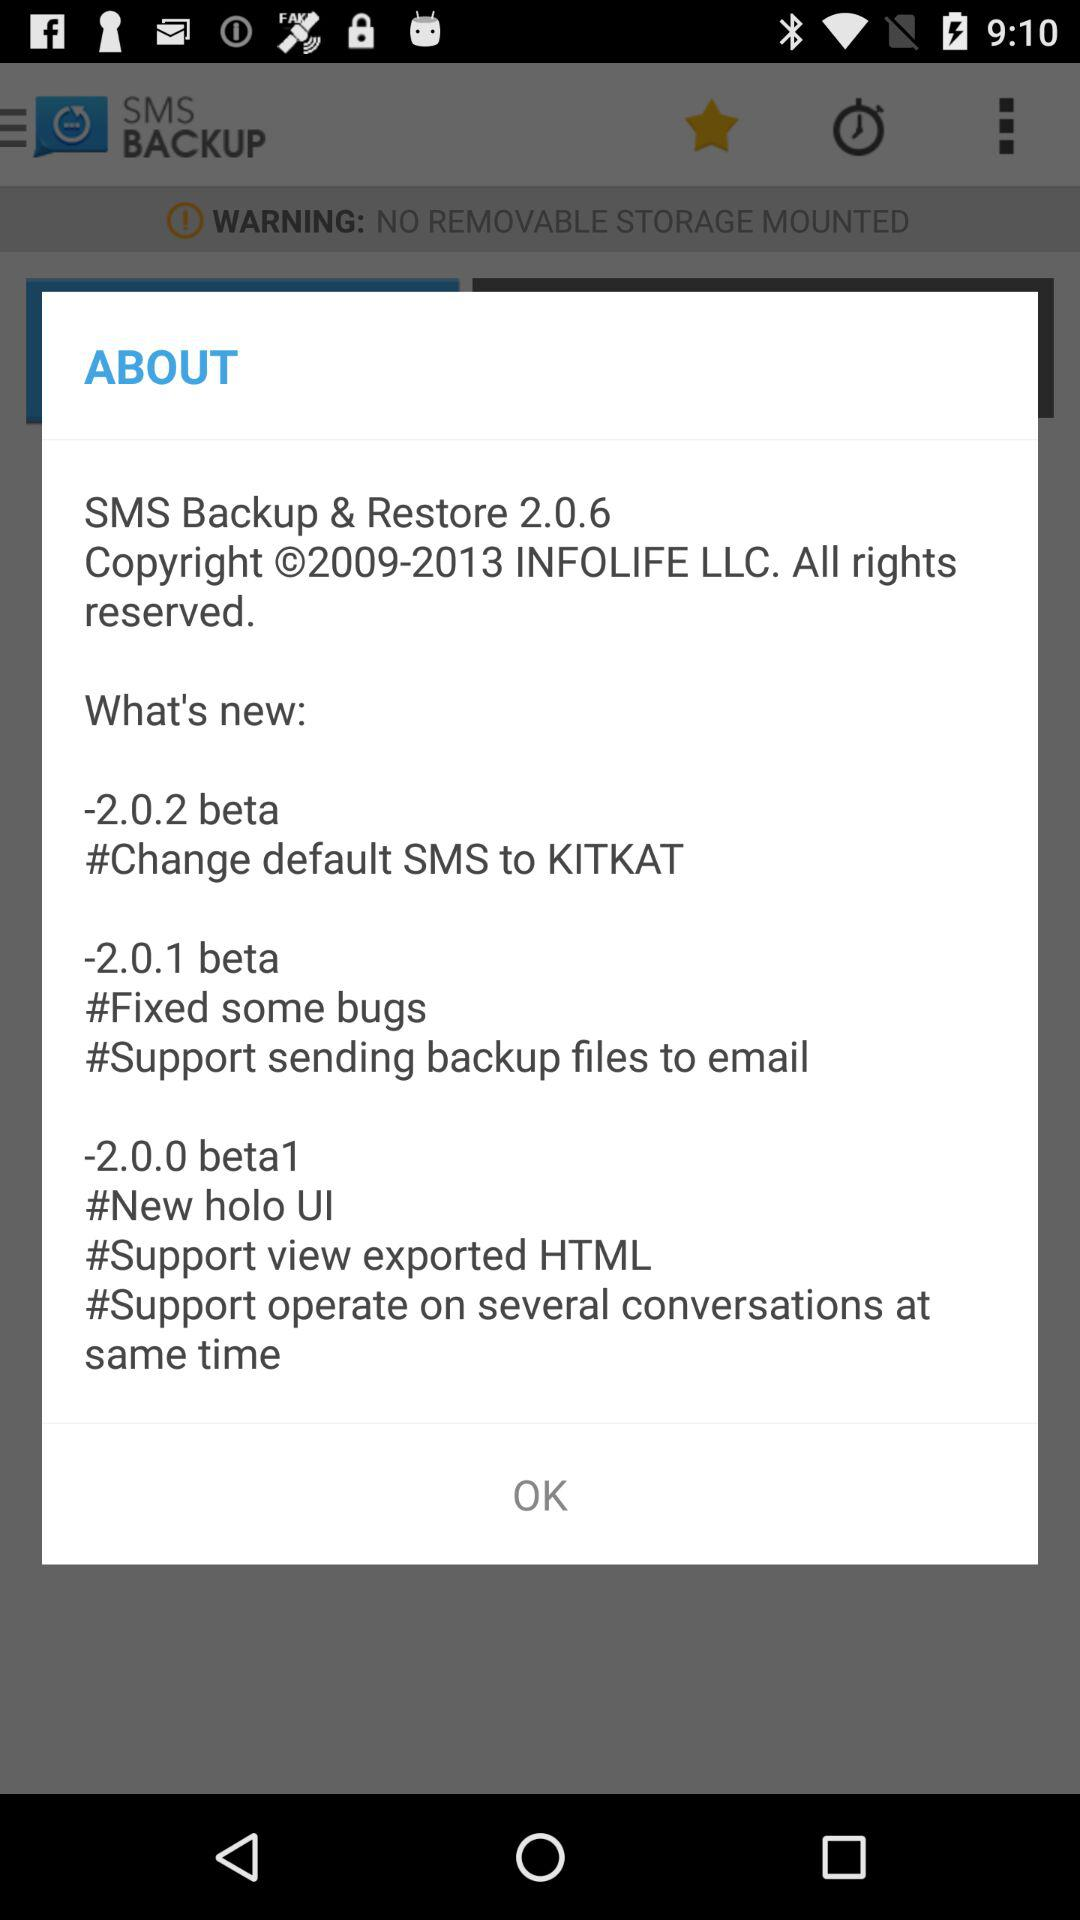What are the new features in version 2.0.2 beta? The new feature is "Change default SMS to KITKAT". 